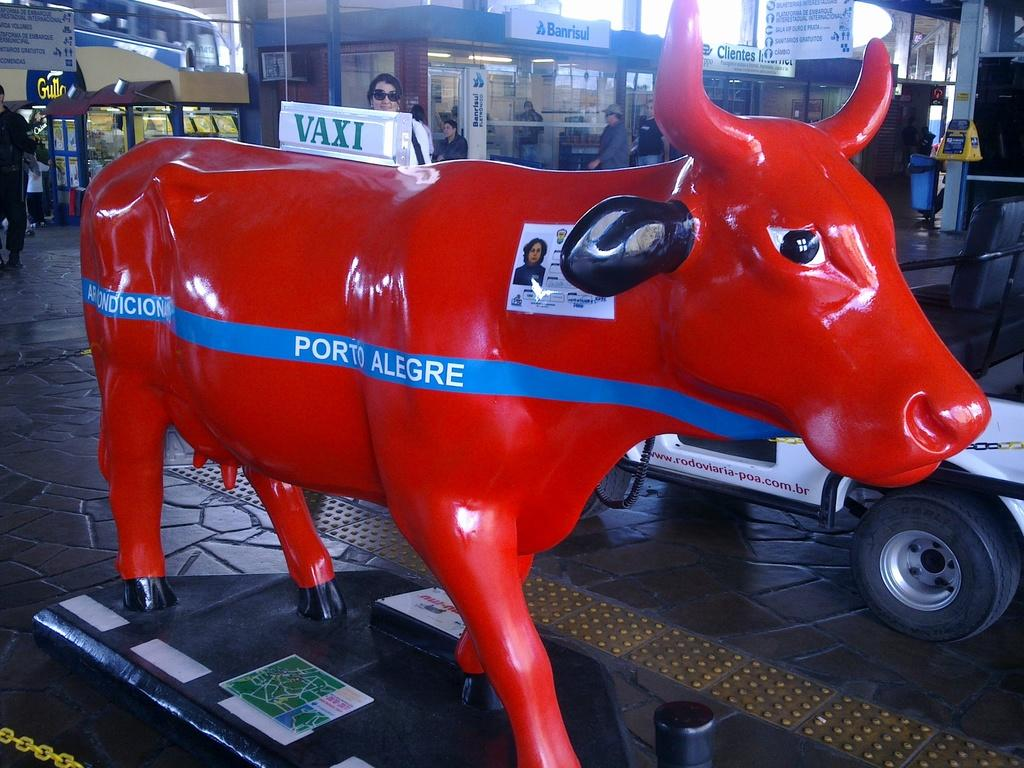What type of surface can be seen in the image? There is ground visible in the image. What is the statue of an animal in the image colored? The statue is red in color. Can you describe the people in the image? There are people standing in the image. What else can be seen in the image besides the statue and people? There are vehicles and buildings in the image. What is visible in the background of the image? The sky and boards are visible in the background of the image. What time of day does the image depict, and how does the statue show respect? The time of day is not mentioned in the image, and the statue does not show respect as it is an inanimate object. 